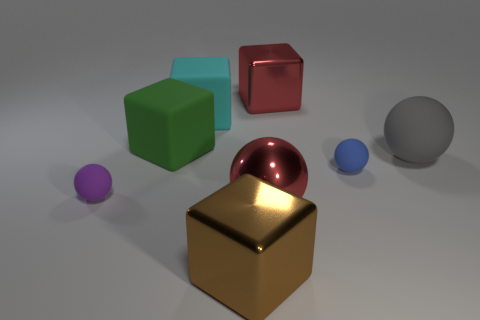Add 1 green matte cubes. How many objects exist? 9 Add 2 big brown shiny objects. How many big brown shiny objects are left? 3 Add 7 metal cubes. How many metal cubes exist? 9 Subtract 0 purple cylinders. How many objects are left? 8 Subtract all small yellow matte objects. Subtract all big red blocks. How many objects are left? 7 